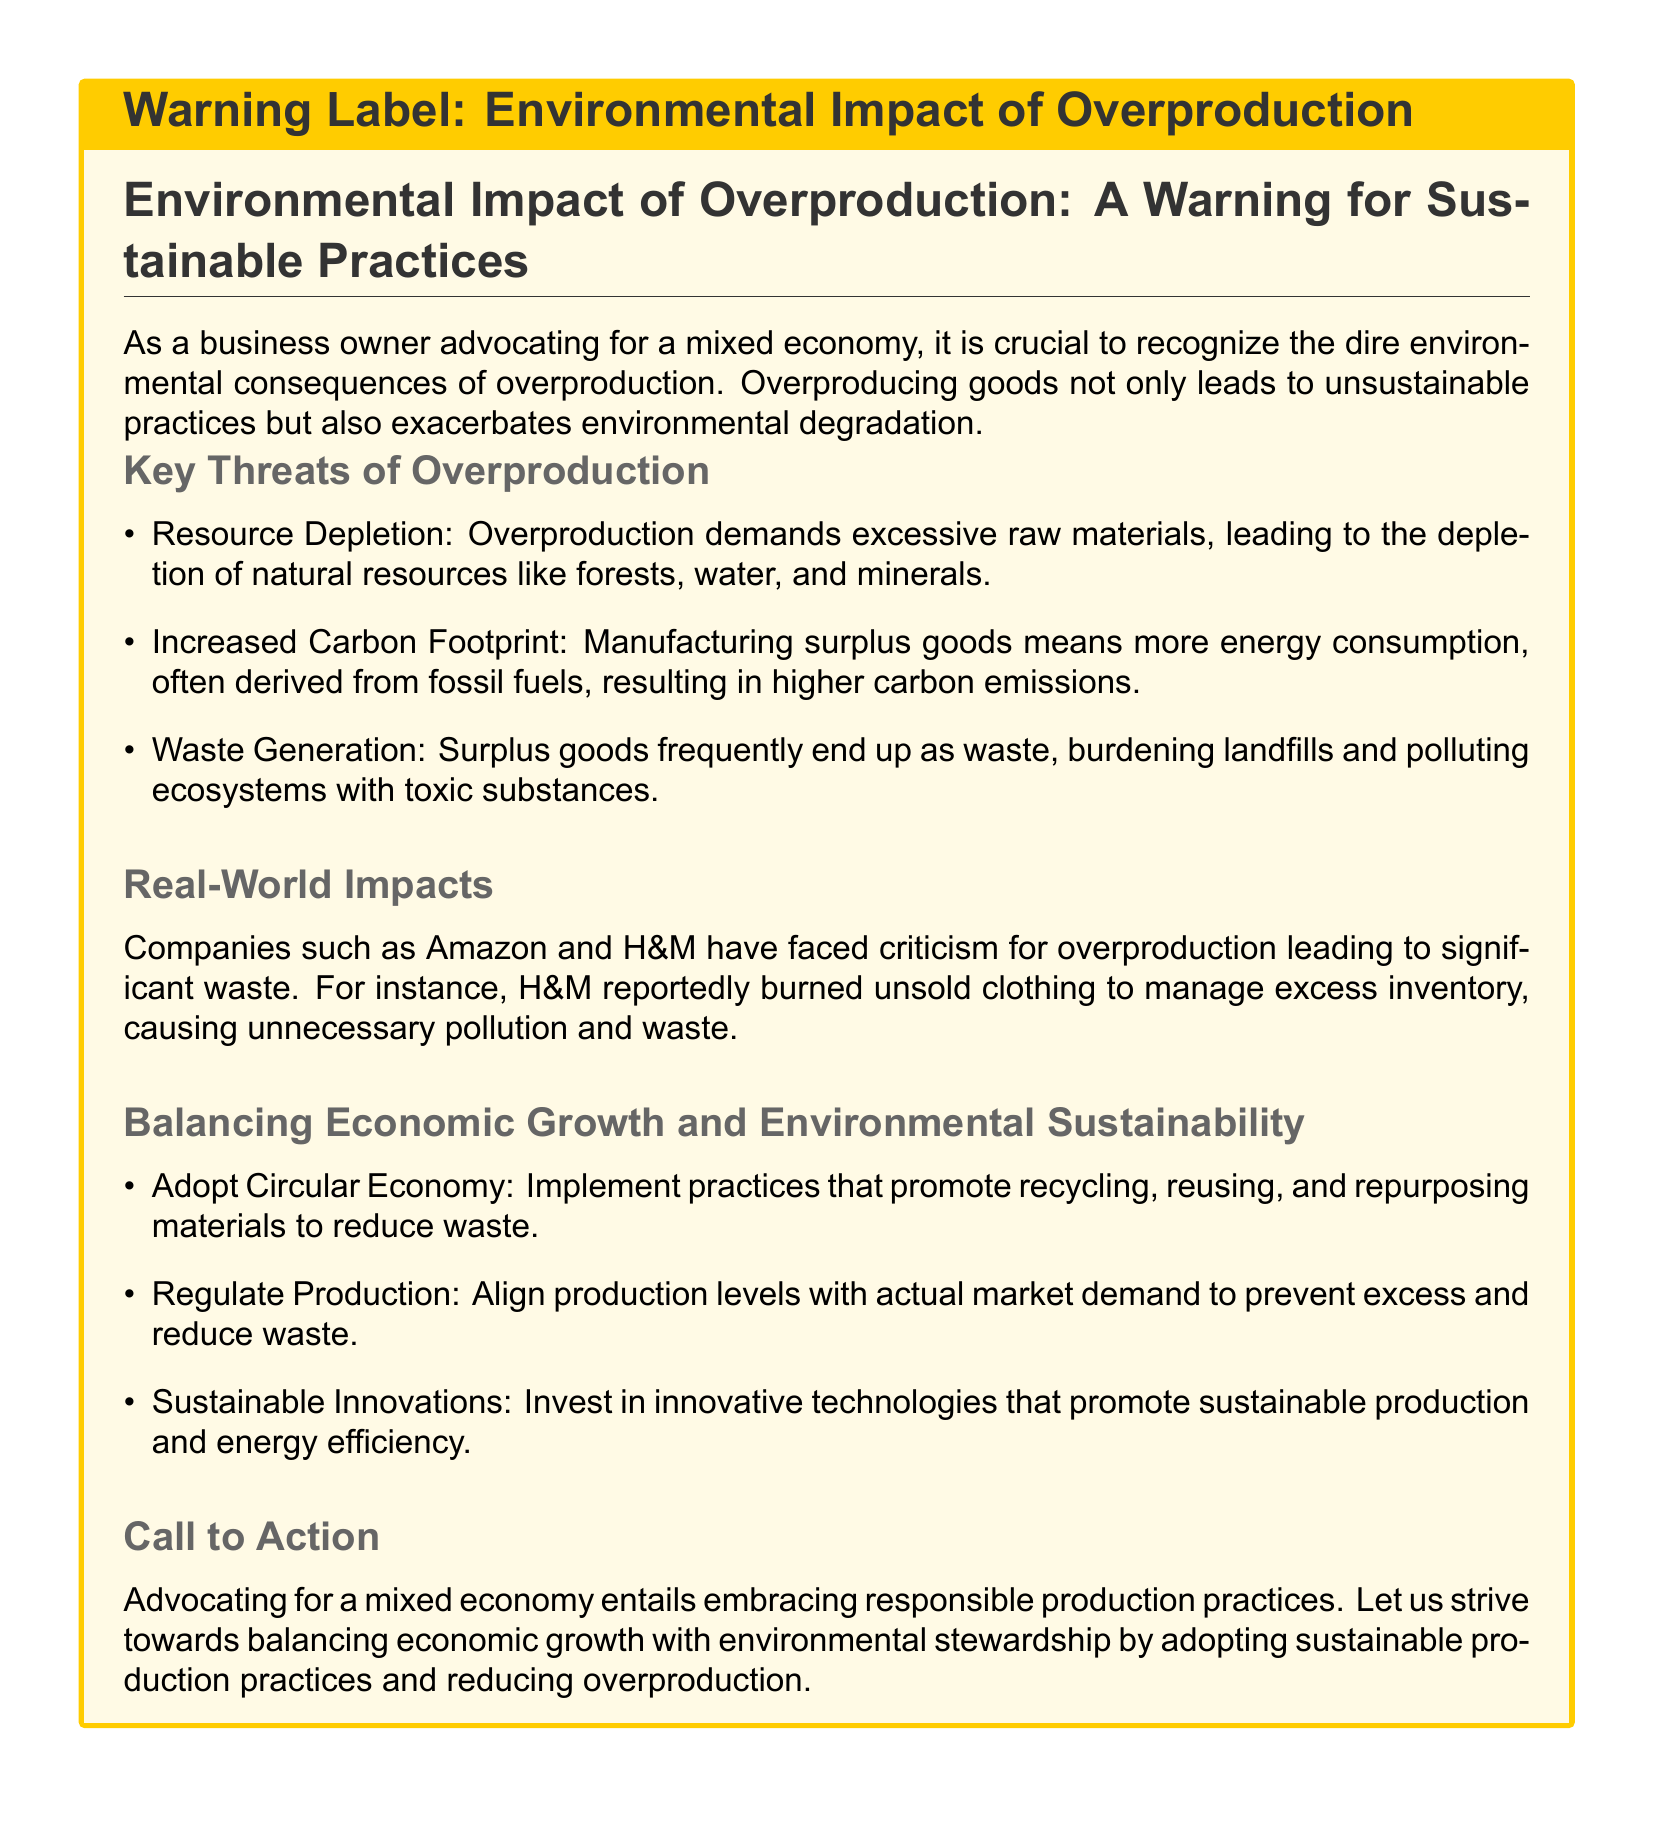What is the main topic of the warning label? The main topic is the environmental impact of overproduction and sustainable practices.
Answer: Environmental Impact of Overproduction What color is used for the warning label's title background? The background color for the title is set to warningcolor, which is an RGB value of 255,204,0.
Answer: RGB 255,204,0 Which companies are mentioned in relation to overproduction? The document specifically mentions Amazon and H&M for their practices causing significant waste.
Answer: Amazon and H&M What are two key threats of overproduction listed? The document lists resource depletion and increased carbon footprint as key threats.
Answer: Resource Depletion, Increased Carbon Footprint What sustainable practice is suggested to reduce waste? The document suggests adopting a circular economy to promote recycling and repurposing materials.
Answer: Circular Economy What action does the warning label urge business owners to take? The warning label calls for advocating responsible production practices.
Answer: Advocating responsible production practices How does overproduction impact carbon emissions? Overproducing goods leads to more energy consumption, resulting in higher carbon emissions.
Answer: Higher carbon emissions What is one way to balance economic growth and environmental sustainability? One way mentioned is regulating production to align with market demand.
Answer: Regulate Production What infamous practice did H&M reportedly engage in? H&M reportedly burned unsold clothing to manage excess inventory.
Answer: Burned unsold clothing 